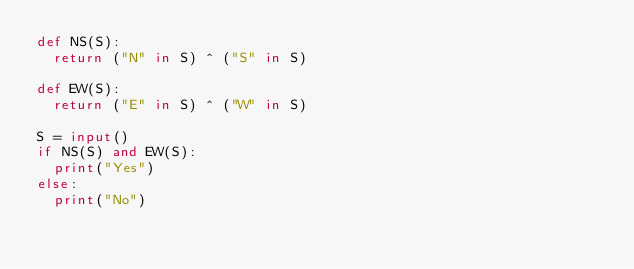<code> <loc_0><loc_0><loc_500><loc_500><_Python_>def NS(S):
  return ("N" in S) ^ ("S" in S)

def EW(S):
  return ("E" in S) ^ ("W" in S)

S = input()
if NS(S) and EW(S):
  print("Yes")
else:
  print("No")
</code> 